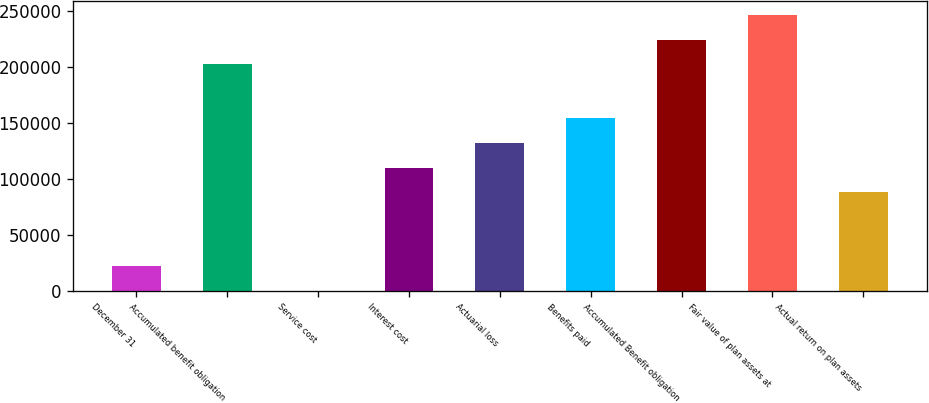<chart> <loc_0><loc_0><loc_500><loc_500><bar_chart><fcel>December 31<fcel>Accumulated benefit obligation<fcel>Service cost<fcel>Interest cost<fcel>Actuarial loss<fcel>Benefits paid<fcel>Accumulated Benefit obligation<fcel>Fair value of plan assets at<fcel>Actual return on plan assets<nl><fcel>22023.8<fcel>202310<fcel>37<fcel>109971<fcel>131958<fcel>153945<fcel>224297<fcel>246284<fcel>87984.2<nl></chart> 